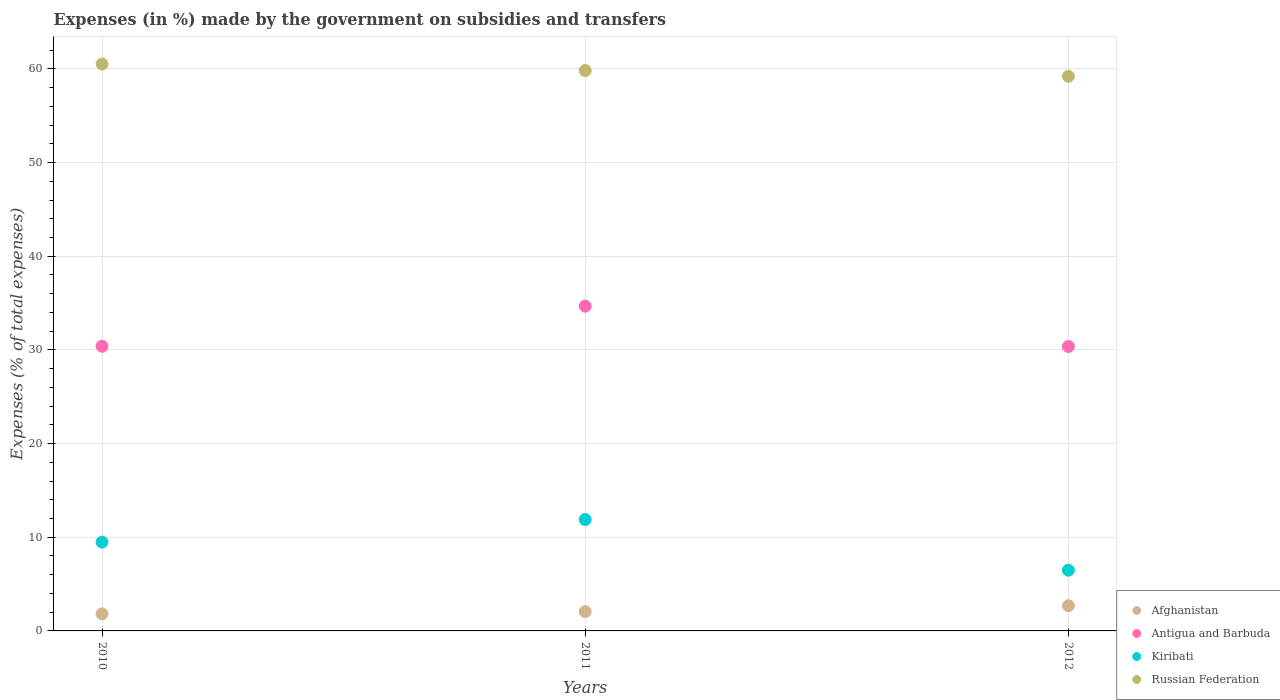How many different coloured dotlines are there?
Keep it short and to the point. 4. Is the number of dotlines equal to the number of legend labels?
Ensure brevity in your answer.  Yes. What is the percentage of expenses made by the government on subsidies and transfers in Antigua and Barbuda in 2010?
Offer a terse response. 30.39. Across all years, what is the maximum percentage of expenses made by the government on subsidies and transfers in Antigua and Barbuda?
Keep it short and to the point. 34.67. Across all years, what is the minimum percentage of expenses made by the government on subsidies and transfers in Kiribati?
Keep it short and to the point. 6.48. In which year was the percentage of expenses made by the government on subsidies and transfers in Afghanistan minimum?
Provide a succinct answer. 2010. What is the total percentage of expenses made by the government on subsidies and transfers in Russian Federation in the graph?
Provide a succinct answer. 179.55. What is the difference between the percentage of expenses made by the government on subsidies and transfers in Antigua and Barbuda in 2010 and that in 2012?
Give a very brief answer. 0.03. What is the difference between the percentage of expenses made by the government on subsidies and transfers in Russian Federation in 2011 and the percentage of expenses made by the government on subsidies and transfers in Kiribati in 2012?
Keep it short and to the point. 53.34. What is the average percentage of expenses made by the government on subsidies and transfers in Antigua and Barbuda per year?
Offer a very short reply. 31.81. In the year 2011, what is the difference between the percentage of expenses made by the government on subsidies and transfers in Antigua and Barbuda and percentage of expenses made by the government on subsidies and transfers in Kiribati?
Your answer should be very brief. 22.78. What is the ratio of the percentage of expenses made by the government on subsidies and transfers in Russian Federation in 2010 to that in 2011?
Your answer should be very brief. 1.01. Is the percentage of expenses made by the government on subsidies and transfers in Kiribati in 2011 less than that in 2012?
Your response must be concise. No. Is the difference between the percentage of expenses made by the government on subsidies and transfers in Antigua and Barbuda in 2010 and 2012 greater than the difference between the percentage of expenses made by the government on subsidies and transfers in Kiribati in 2010 and 2012?
Give a very brief answer. No. What is the difference between the highest and the second highest percentage of expenses made by the government on subsidies and transfers in Afghanistan?
Offer a very short reply. 0.63. What is the difference between the highest and the lowest percentage of expenses made by the government on subsidies and transfers in Afghanistan?
Give a very brief answer. 0.87. In how many years, is the percentage of expenses made by the government on subsidies and transfers in Kiribati greater than the average percentage of expenses made by the government on subsidies and transfers in Kiribati taken over all years?
Give a very brief answer. 2. Does the percentage of expenses made by the government on subsidies and transfers in Russian Federation monotonically increase over the years?
Keep it short and to the point. No. Is the percentage of expenses made by the government on subsidies and transfers in Kiribati strictly greater than the percentage of expenses made by the government on subsidies and transfers in Afghanistan over the years?
Offer a very short reply. Yes. How many dotlines are there?
Give a very brief answer. 4. What is the difference between two consecutive major ticks on the Y-axis?
Offer a very short reply. 10. Are the values on the major ticks of Y-axis written in scientific E-notation?
Give a very brief answer. No. Does the graph contain grids?
Your response must be concise. Yes. Where does the legend appear in the graph?
Keep it short and to the point. Bottom right. How many legend labels are there?
Provide a short and direct response. 4. How are the legend labels stacked?
Offer a very short reply. Vertical. What is the title of the graph?
Your response must be concise. Expenses (in %) made by the government on subsidies and transfers. What is the label or title of the X-axis?
Provide a short and direct response. Years. What is the label or title of the Y-axis?
Provide a succinct answer. Expenses (% of total expenses). What is the Expenses (% of total expenses) in Afghanistan in 2010?
Ensure brevity in your answer.  1.82. What is the Expenses (% of total expenses) of Antigua and Barbuda in 2010?
Provide a succinct answer. 30.39. What is the Expenses (% of total expenses) in Kiribati in 2010?
Make the answer very short. 9.48. What is the Expenses (% of total expenses) of Russian Federation in 2010?
Offer a terse response. 60.52. What is the Expenses (% of total expenses) of Afghanistan in 2011?
Offer a very short reply. 2.06. What is the Expenses (% of total expenses) of Antigua and Barbuda in 2011?
Keep it short and to the point. 34.67. What is the Expenses (% of total expenses) of Kiribati in 2011?
Your response must be concise. 11.89. What is the Expenses (% of total expenses) of Russian Federation in 2011?
Keep it short and to the point. 59.83. What is the Expenses (% of total expenses) in Afghanistan in 2012?
Give a very brief answer. 2.69. What is the Expenses (% of total expenses) in Antigua and Barbuda in 2012?
Your answer should be very brief. 30.36. What is the Expenses (% of total expenses) of Kiribati in 2012?
Make the answer very short. 6.48. What is the Expenses (% of total expenses) in Russian Federation in 2012?
Your answer should be very brief. 59.21. Across all years, what is the maximum Expenses (% of total expenses) of Afghanistan?
Ensure brevity in your answer.  2.69. Across all years, what is the maximum Expenses (% of total expenses) of Antigua and Barbuda?
Ensure brevity in your answer.  34.67. Across all years, what is the maximum Expenses (% of total expenses) of Kiribati?
Offer a very short reply. 11.89. Across all years, what is the maximum Expenses (% of total expenses) in Russian Federation?
Ensure brevity in your answer.  60.52. Across all years, what is the minimum Expenses (% of total expenses) of Afghanistan?
Offer a very short reply. 1.82. Across all years, what is the minimum Expenses (% of total expenses) of Antigua and Barbuda?
Keep it short and to the point. 30.36. Across all years, what is the minimum Expenses (% of total expenses) of Kiribati?
Give a very brief answer. 6.48. Across all years, what is the minimum Expenses (% of total expenses) in Russian Federation?
Offer a very short reply. 59.21. What is the total Expenses (% of total expenses) of Afghanistan in the graph?
Offer a terse response. 6.58. What is the total Expenses (% of total expenses) in Antigua and Barbuda in the graph?
Your answer should be compact. 95.43. What is the total Expenses (% of total expenses) in Kiribati in the graph?
Offer a very short reply. 27.85. What is the total Expenses (% of total expenses) of Russian Federation in the graph?
Your response must be concise. 179.55. What is the difference between the Expenses (% of total expenses) of Afghanistan in 2010 and that in 2011?
Ensure brevity in your answer.  -0.24. What is the difference between the Expenses (% of total expenses) of Antigua and Barbuda in 2010 and that in 2011?
Ensure brevity in your answer.  -4.28. What is the difference between the Expenses (% of total expenses) of Kiribati in 2010 and that in 2011?
Provide a short and direct response. -2.41. What is the difference between the Expenses (% of total expenses) of Russian Federation in 2010 and that in 2011?
Give a very brief answer. 0.69. What is the difference between the Expenses (% of total expenses) of Afghanistan in 2010 and that in 2012?
Make the answer very short. -0.87. What is the difference between the Expenses (% of total expenses) in Antigua and Barbuda in 2010 and that in 2012?
Your response must be concise. 0.03. What is the difference between the Expenses (% of total expenses) in Kiribati in 2010 and that in 2012?
Ensure brevity in your answer.  2.99. What is the difference between the Expenses (% of total expenses) of Russian Federation in 2010 and that in 2012?
Provide a succinct answer. 1.31. What is the difference between the Expenses (% of total expenses) in Afghanistan in 2011 and that in 2012?
Make the answer very short. -0.63. What is the difference between the Expenses (% of total expenses) in Antigua and Barbuda in 2011 and that in 2012?
Your response must be concise. 4.31. What is the difference between the Expenses (% of total expenses) of Kiribati in 2011 and that in 2012?
Keep it short and to the point. 5.41. What is the difference between the Expenses (% of total expenses) of Russian Federation in 2011 and that in 2012?
Provide a short and direct response. 0.62. What is the difference between the Expenses (% of total expenses) of Afghanistan in 2010 and the Expenses (% of total expenses) of Antigua and Barbuda in 2011?
Provide a short and direct response. -32.85. What is the difference between the Expenses (% of total expenses) in Afghanistan in 2010 and the Expenses (% of total expenses) in Kiribati in 2011?
Give a very brief answer. -10.07. What is the difference between the Expenses (% of total expenses) in Afghanistan in 2010 and the Expenses (% of total expenses) in Russian Federation in 2011?
Your response must be concise. -58. What is the difference between the Expenses (% of total expenses) in Antigua and Barbuda in 2010 and the Expenses (% of total expenses) in Kiribati in 2011?
Provide a succinct answer. 18.5. What is the difference between the Expenses (% of total expenses) of Antigua and Barbuda in 2010 and the Expenses (% of total expenses) of Russian Federation in 2011?
Your answer should be compact. -29.43. What is the difference between the Expenses (% of total expenses) in Kiribati in 2010 and the Expenses (% of total expenses) in Russian Federation in 2011?
Give a very brief answer. -50.35. What is the difference between the Expenses (% of total expenses) in Afghanistan in 2010 and the Expenses (% of total expenses) in Antigua and Barbuda in 2012?
Your answer should be very brief. -28.54. What is the difference between the Expenses (% of total expenses) in Afghanistan in 2010 and the Expenses (% of total expenses) in Kiribati in 2012?
Ensure brevity in your answer.  -4.66. What is the difference between the Expenses (% of total expenses) of Afghanistan in 2010 and the Expenses (% of total expenses) of Russian Federation in 2012?
Provide a succinct answer. -57.38. What is the difference between the Expenses (% of total expenses) in Antigua and Barbuda in 2010 and the Expenses (% of total expenses) in Kiribati in 2012?
Your response must be concise. 23.91. What is the difference between the Expenses (% of total expenses) in Antigua and Barbuda in 2010 and the Expenses (% of total expenses) in Russian Federation in 2012?
Provide a succinct answer. -28.82. What is the difference between the Expenses (% of total expenses) of Kiribati in 2010 and the Expenses (% of total expenses) of Russian Federation in 2012?
Your answer should be very brief. -49.73. What is the difference between the Expenses (% of total expenses) of Afghanistan in 2011 and the Expenses (% of total expenses) of Antigua and Barbuda in 2012?
Offer a very short reply. -28.3. What is the difference between the Expenses (% of total expenses) in Afghanistan in 2011 and the Expenses (% of total expenses) in Kiribati in 2012?
Your answer should be compact. -4.42. What is the difference between the Expenses (% of total expenses) in Afghanistan in 2011 and the Expenses (% of total expenses) in Russian Federation in 2012?
Ensure brevity in your answer.  -57.15. What is the difference between the Expenses (% of total expenses) in Antigua and Barbuda in 2011 and the Expenses (% of total expenses) in Kiribati in 2012?
Give a very brief answer. 28.19. What is the difference between the Expenses (% of total expenses) in Antigua and Barbuda in 2011 and the Expenses (% of total expenses) in Russian Federation in 2012?
Provide a short and direct response. -24.54. What is the difference between the Expenses (% of total expenses) of Kiribati in 2011 and the Expenses (% of total expenses) of Russian Federation in 2012?
Keep it short and to the point. -47.32. What is the average Expenses (% of total expenses) in Afghanistan per year?
Provide a short and direct response. 2.19. What is the average Expenses (% of total expenses) in Antigua and Barbuda per year?
Offer a very short reply. 31.81. What is the average Expenses (% of total expenses) of Kiribati per year?
Give a very brief answer. 9.29. What is the average Expenses (% of total expenses) in Russian Federation per year?
Keep it short and to the point. 59.85. In the year 2010, what is the difference between the Expenses (% of total expenses) of Afghanistan and Expenses (% of total expenses) of Antigua and Barbuda?
Your answer should be compact. -28.57. In the year 2010, what is the difference between the Expenses (% of total expenses) in Afghanistan and Expenses (% of total expenses) in Kiribati?
Your answer should be very brief. -7.65. In the year 2010, what is the difference between the Expenses (% of total expenses) of Afghanistan and Expenses (% of total expenses) of Russian Federation?
Give a very brief answer. -58.69. In the year 2010, what is the difference between the Expenses (% of total expenses) of Antigua and Barbuda and Expenses (% of total expenses) of Kiribati?
Offer a very short reply. 20.91. In the year 2010, what is the difference between the Expenses (% of total expenses) in Antigua and Barbuda and Expenses (% of total expenses) in Russian Federation?
Give a very brief answer. -30.13. In the year 2010, what is the difference between the Expenses (% of total expenses) in Kiribati and Expenses (% of total expenses) in Russian Federation?
Ensure brevity in your answer.  -51.04. In the year 2011, what is the difference between the Expenses (% of total expenses) in Afghanistan and Expenses (% of total expenses) in Antigua and Barbuda?
Provide a short and direct response. -32.61. In the year 2011, what is the difference between the Expenses (% of total expenses) in Afghanistan and Expenses (% of total expenses) in Kiribati?
Offer a very short reply. -9.83. In the year 2011, what is the difference between the Expenses (% of total expenses) in Afghanistan and Expenses (% of total expenses) in Russian Federation?
Provide a short and direct response. -57.76. In the year 2011, what is the difference between the Expenses (% of total expenses) of Antigua and Barbuda and Expenses (% of total expenses) of Kiribati?
Offer a terse response. 22.78. In the year 2011, what is the difference between the Expenses (% of total expenses) of Antigua and Barbuda and Expenses (% of total expenses) of Russian Federation?
Offer a terse response. -25.15. In the year 2011, what is the difference between the Expenses (% of total expenses) in Kiribati and Expenses (% of total expenses) in Russian Federation?
Your answer should be compact. -47.93. In the year 2012, what is the difference between the Expenses (% of total expenses) of Afghanistan and Expenses (% of total expenses) of Antigua and Barbuda?
Offer a very short reply. -27.67. In the year 2012, what is the difference between the Expenses (% of total expenses) in Afghanistan and Expenses (% of total expenses) in Kiribati?
Ensure brevity in your answer.  -3.79. In the year 2012, what is the difference between the Expenses (% of total expenses) in Afghanistan and Expenses (% of total expenses) in Russian Federation?
Make the answer very short. -56.52. In the year 2012, what is the difference between the Expenses (% of total expenses) in Antigua and Barbuda and Expenses (% of total expenses) in Kiribati?
Your answer should be compact. 23.88. In the year 2012, what is the difference between the Expenses (% of total expenses) in Antigua and Barbuda and Expenses (% of total expenses) in Russian Federation?
Your answer should be compact. -28.84. In the year 2012, what is the difference between the Expenses (% of total expenses) in Kiribati and Expenses (% of total expenses) in Russian Federation?
Make the answer very short. -52.73. What is the ratio of the Expenses (% of total expenses) of Afghanistan in 2010 to that in 2011?
Provide a short and direct response. 0.89. What is the ratio of the Expenses (% of total expenses) in Antigua and Barbuda in 2010 to that in 2011?
Keep it short and to the point. 0.88. What is the ratio of the Expenses (% of total expenses) of Kiribati in 2010 to that in 2011?
Your response must be concise. 0.8. What is the ratio of the Expenses (% of total expenses) of Russian Federation in 2010 to that in 2011?
Give a very brief answer. 1.01. What is the ratio of the Expenses (% of total expenses) of Afghanistan in 2010 to that in 2012?
Offer a terse response. 0.68. What is the ratio of the Expenses (% of total expenses) in Antigua and Barbuda in 2010 to that in 2012?
Your answer should be very brief. 1. What is the ratio of the Expenses (% of total expenses) of Kiribati in 2010 to that in 2012?
Provide a short and direct response. 1.46. What is the ratio of the Expenses (% of total expenses) in Russian Federation in 2010 to that in 2012?
Make the answer very short. 1.02. What is the ratio of the Expenses (% of total expenses) of Afghanistan in 2011 to that in 2012?
Ensure brevity in your answer.  0.77. What is the ratio of the Expenses (% of total expenses) of Antigua and Barbuda in 2011 to that in 2012?
Your response must be concise. 1.14. What is the ratio of the Expenses (% of total expenses) of Kiribati in 2011 to that in 2012?
Ensure brevity in your answer.  1.83. What is the ratio of the Expenses (% of total expenses) of Russian Federation in 2011 to that in 2012?
Keep it short and to the point. 1.01. What is the difference between the highest and the second highest Expenses (% of total expenses) in Afghanistan?
Your answer should be very brief. 0.63. What is the difference between the highest and the second highest Expenses (% of total expenses) in Antigua and Barbuda?
Your answer should be very brief. 4.28. What is the difference between the highest and the second highest Expenses (% of total expenses) of Kiribati?
Offer a very short reply. 2.41. What is the difference between the highest and the second highest Expenses (% of total expenses) of Russian Federation?
Your answer should be compact. 0.69. What is the difference between the highest and the lowest Expenses (% of total expenses) in Afghanistan?
Keep it short and to the point. 0.87. What is the difference between the highest and the lowest Expenses (% of total expenses) in Antigua and Barbuda?
Your answer should be compact. 4.31. What is the difference between the highest and the lowest Expenses (% of total expenses) of Kiribati?
Offer a terse response. 5.41. What is the difference between the highest and the lowest Expenses (% of total expenses) in Russian Federation?
Keep it short and to the point. 1.31. 